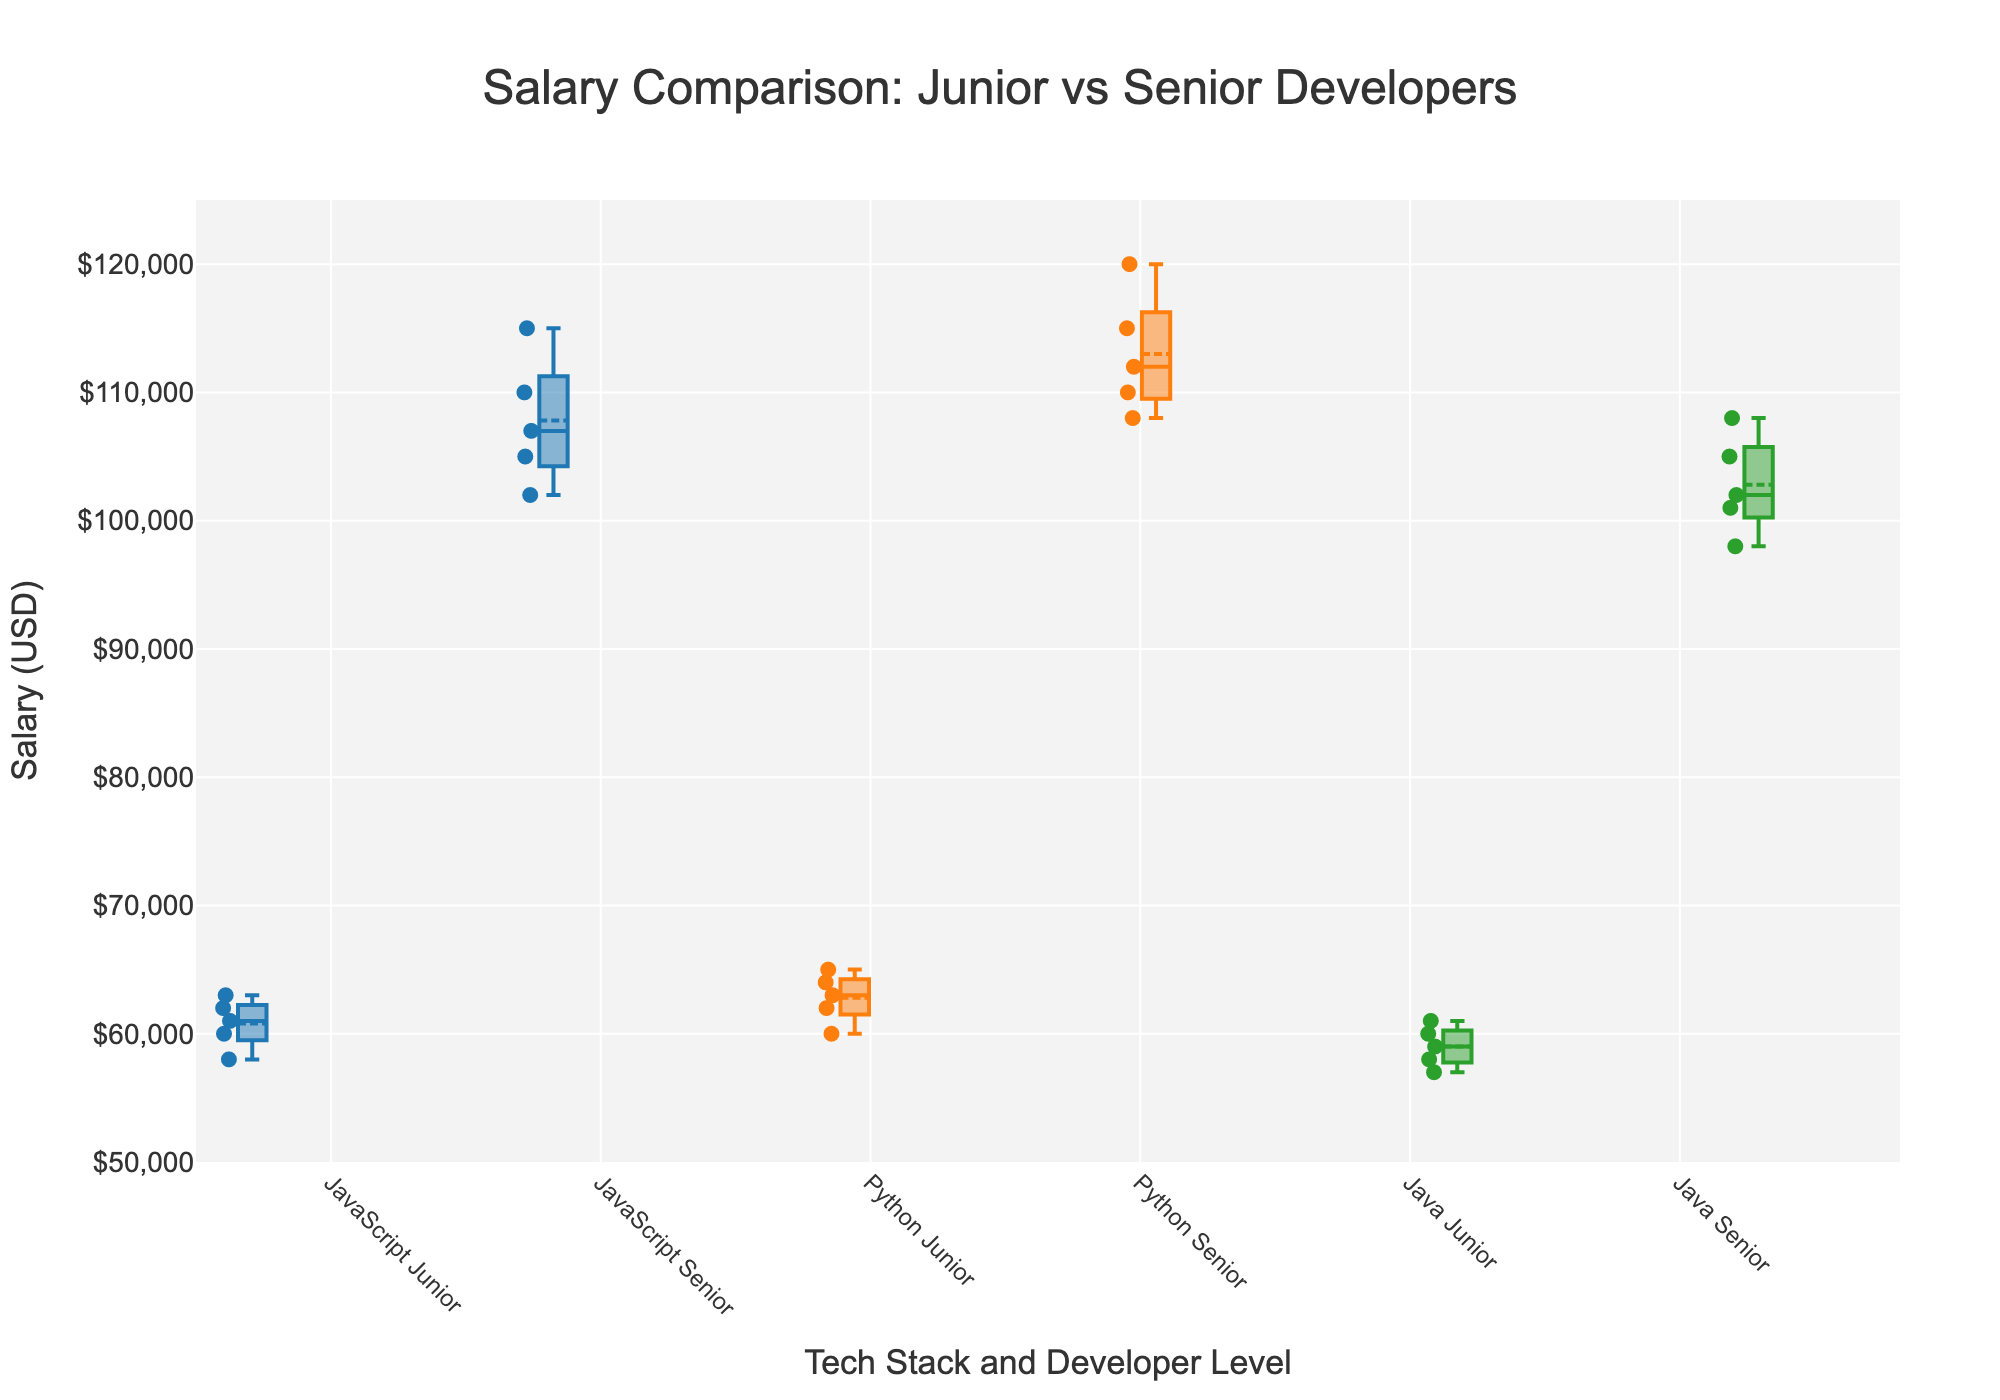What's the title of the plot? The title of the plot is located at the top of the figure in larger font size. It is "Salary Comparison: Junior vs Senior Developers".
Answer: Salary Comparison: Junior vs Senior Developers What is the median salary for senior Python developers? For senior Python developers, refer to the box corresponding to them. The median is the line inside this box. Since this is a grouped box plot, look for the label "Python Senior" on the x-axis and check the corresponding box’s center line location.
Answer: 112000 Which tech stack has the widest salary range for junior developers? The width, or range, of the salaries is shown by the length of the box from the bottom to the top whisker. Comparing the three boxes for junior developers (JavaScript, Python, Java), the JavaScript Junior box visually spans the most significant range on the y-axis.
Answer: JavaScript Are senior developers' salaries generally higher than junior developers' salaries within each tech stack? Compare the boxes for each tech stack (JavaScript, Python, Java). For all three tech stacks, the senior developer boxes are higher on the y-axis compared to the junior developer boxes.
Answer: Yes What is the approximate salary range for junior Java developers? Locate the box for "Java Junior" and examine the bottom and top whiskers, which represent the range from the minimum to the maximum salary. The approximate range can be determined by the y-axis values.
Answer: 57000 to 61000 Which group has the highest maximum salary? The maximum salary is indicated by the top whisker of the box. By comparing the highest points of each box, the "Python Senior" box has the highest whisker on the y-axis.
Answer: Python Senior What is the interquartile range (IQR) for junior Java developers? The IQR is measured by the distance between the first quartile (Q1) and the third quartile (Q3) within a box. For "Java Junior", observe the bottom and upper edges of the box and subtract the y-value of Q1 from Q3. The lower quartile appears close to 58000, and the upper quartile around 60000. 60000 - 58000 = 2000.
Answer: 2000 Can we infer that senior developers are paid more uniformly compared to juniors? Look at the spread of the data points and the size of the boxes (representing the interquartile range) across senior and junior developer groups. Senior developer boxes are generally smaller and more compact compared to junior boxes across tech stacks, indicating less variation.
Answer: Yes What is the most frequent salary value for JavaScript senior developers? In a box plot, the most frequent value is indicated by the mode, which is also often spanned by the line representing the median, as it tends to lie at the densest part of the data. Hence, we look at the median line within the "JavaScript Senior" box.
Answer: 107000 